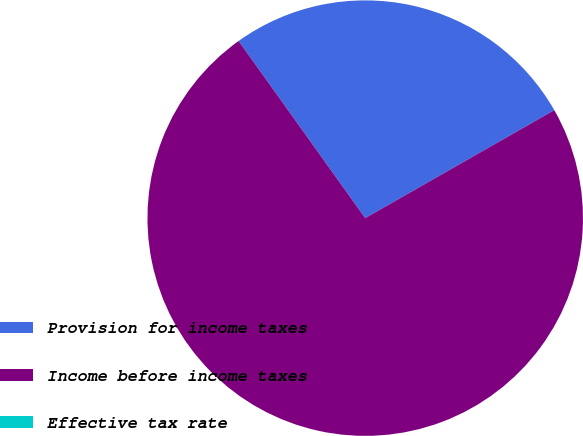Convert chart to OTSL. <chart><loc_0><loc_0><loc_500><loc_500><pie_chart><fcel>Provision for income taxes<fcel>Income before income taxes<fcel>Effective tax rate<nl><fcel>26.62%<fcel>73.38%<fcel>0.0%<nl></chart> 